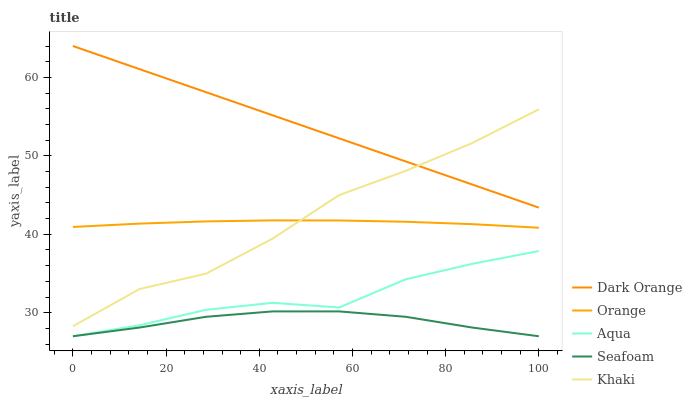Does Seafoam have the minimum area under the curve?
Answer yes or no. Yes. Does Dark Orange have the maximum area under the curve?
Answer yes or no. Yes. Does Khaki have the minimum area under the curve?
Answer yes or no. No. Does Khaki have the maximum area under the curve?
Answer yes or no. No. Is Dark Orange the smoothest?
Answer yes or no. Yes. Is Khaki the roughest?
Answer yes or no. Yes. Is Khaki the smoothest?
Answer yes or no. No. Is Dark Orange the roughest?
Answer yes or no. No. Does Aqua have the lowest value?
Answer yes or no. Yes. Does Khaki have the lowest value?
Answer yes or no. No. Does Dark Orange have the highest value?
Answer yes or no. Yes. Does Khaki have the highest value?
Answer yes or no. No. Is Seafoam less than Orange?
Answer yes or no. Yes. Is Orange greater than Seafoam?
Answer yes or no. Yes. Does Khaki intersect Dark Orange?
Answer yes or no. Yes. Is Khaki less than Dark Orange?
Answer yes or no. No. Is Khaki greater than Dark Orange?
Answer yes or no. No. Does Seafoam intersect Orange?
Answer yes or no. No. 